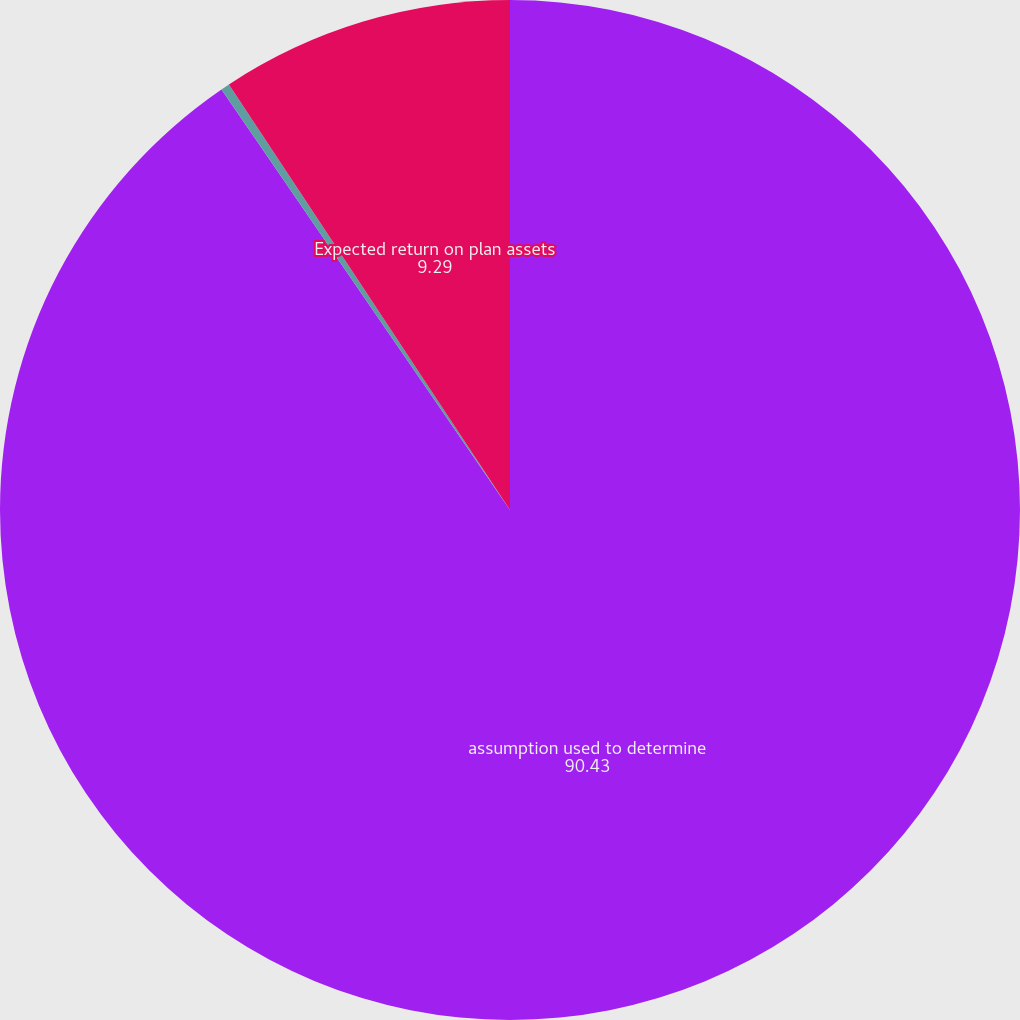Convert chart to OTSL. <chart><loc_0><loc_0><loc_500><loc_500><pie_chart><fcel>assumption used to determine<fcel>Discount rate<fcel>Expected return on plan assets<nl><fcel>90.43%<fcel>0.28%<fcel>9.29%<nl></chart> 